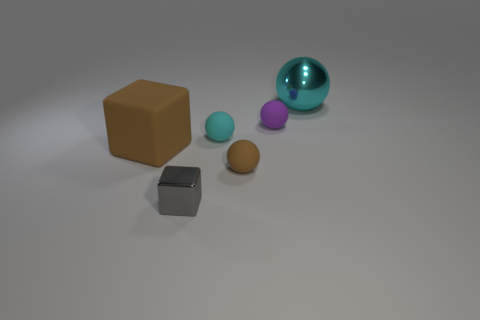What size is the other cyan thing that is the same shape as the small cyan rubber thing?
Your response must be concise. Large. Is the number of cyan objects on the left side of the gray shiny thing the same as the number of tiny shiny blocks that are behind the big block?
Keep it short and to the point. Yes. What number of small red cubes are there?
Provide a short and direct response. 0. Are there more large balls that are to the right of the small brown sphere than large blue shiny cubes?
Provide a short and direct response. Yes. There is a cyan thing on the right side of the small purple rubber thing; what is its material?
Your answer should be compact. Metal. What color is the big shiny thing that is the same shape as the small brown object?
Your answer should be very brief. Cyan. What number of matte balls are the same color as the large block?
Ensure brevity in your answer.  1. Do the cyan object on the left side of the large ball and the metallic thing in front of the purple ball have the same size?
Make the answer very short. Yes. Does the brown rubber cube have the same size as the shiny thing to the right of the tiny brown sphere?
Ensure brevity in your answer.  Yes. What size is the brown block?
Make the answer very short. Large. 